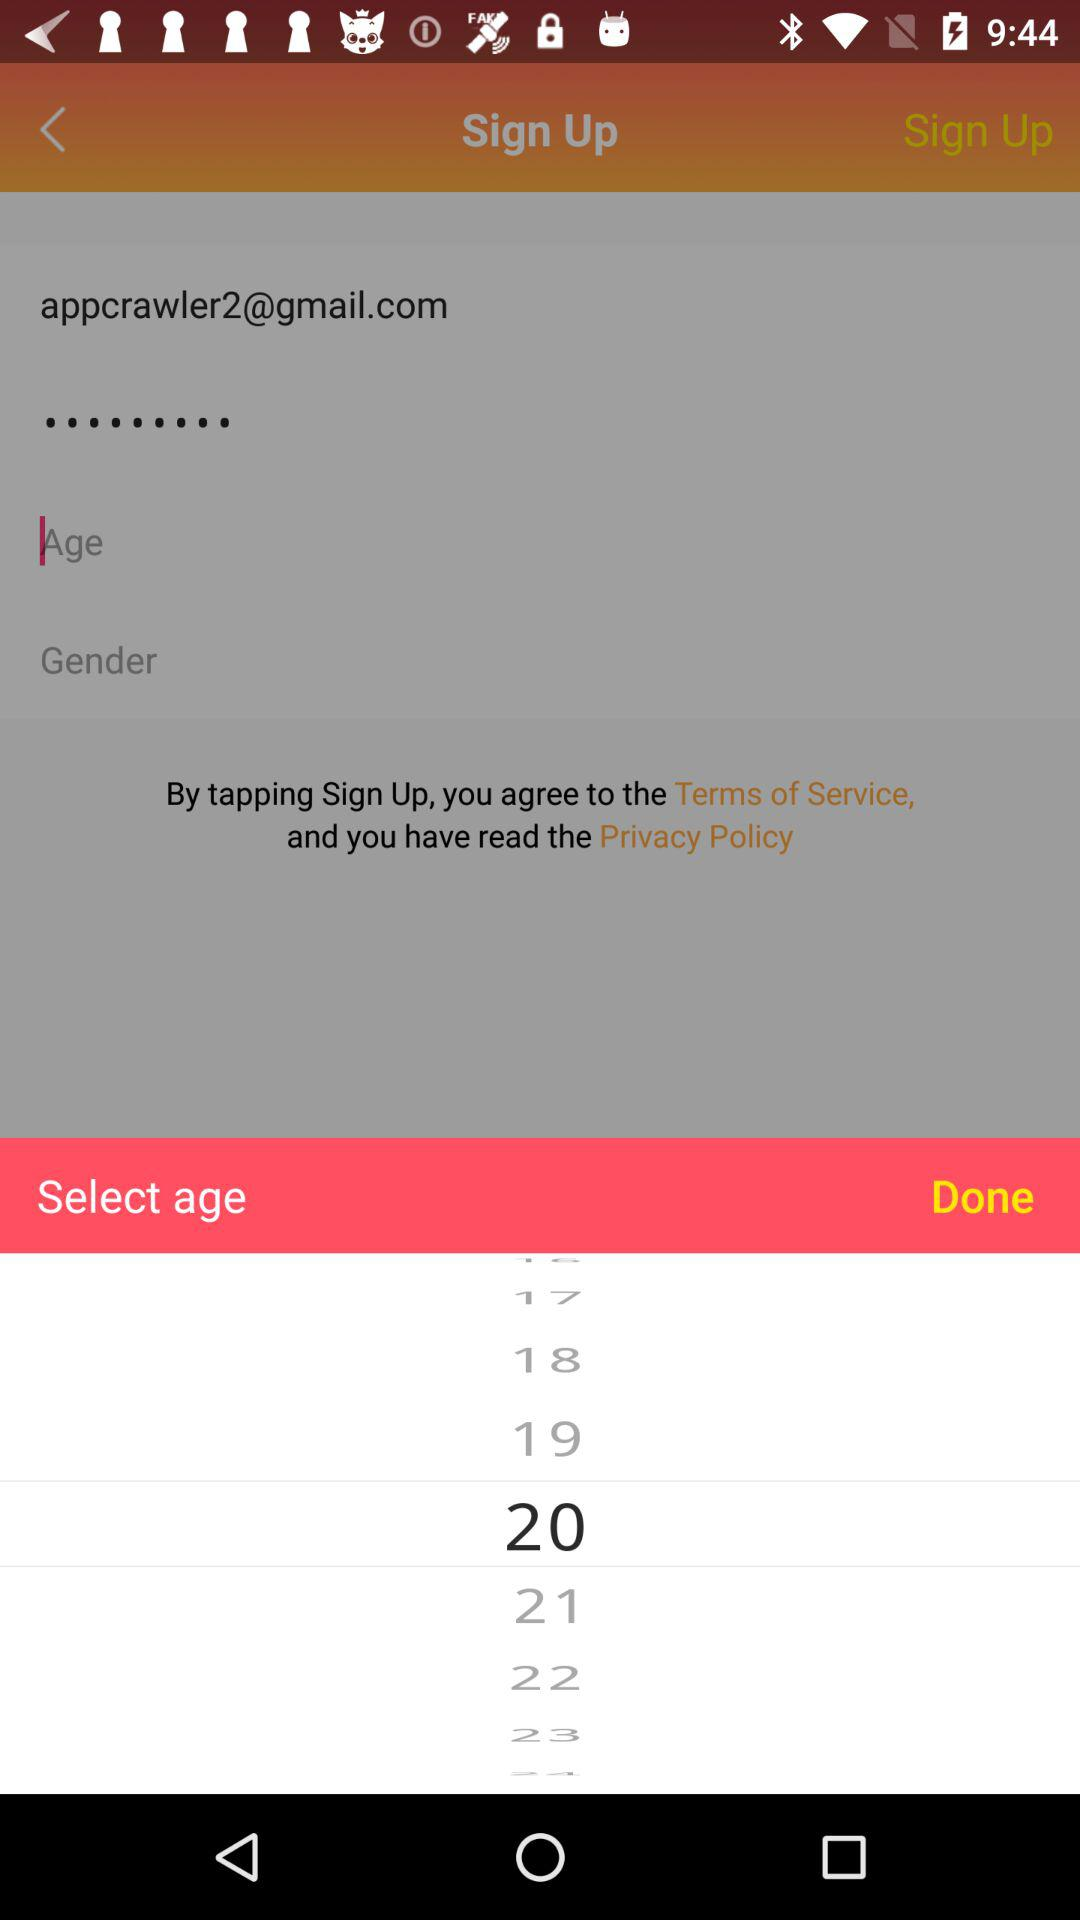What is the email address? The email address is appcrawler2@gmail.com. 